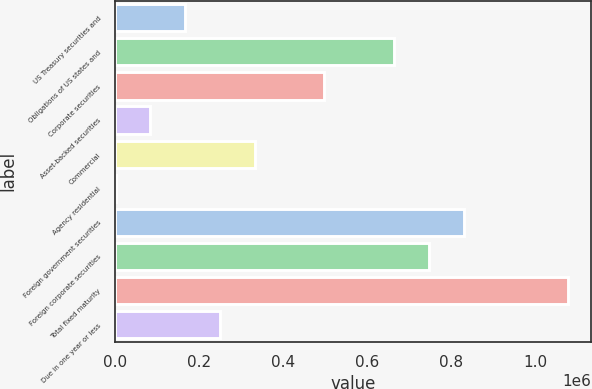Convert chart to OTSL. <chart><loc_0><loc_0><loc_500><loc_500><bar_chart><fcel>US Treasury securities and<fcel>Obligations of US states and<fcel>Corporate securities<fcel>Asset-backed securities<fcel>Commercial<fcel>Agency residential<fcel>Foreign government securities<fcel>Foreign corporate securities<fcel>Total fixed maturity<fcel>Due in one year or less<nl><fcel>166505<fcel>664178<fcel>498287<fcel>83559.5<fcel>332396<fcel>614<fcel>830069<fcel>747124<fcel>1.07891e+06<fcel>249450<nl></chart> 